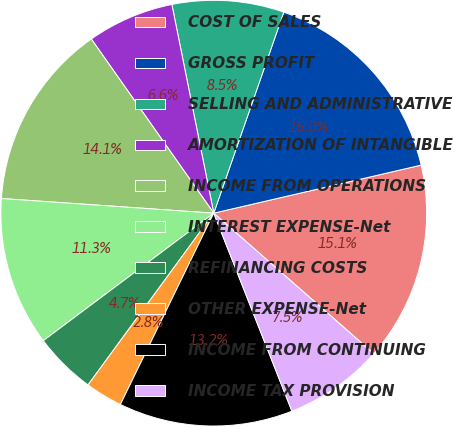<chart> <loc_0><loc_0><loc_500><loc_500><pie_chart><fcel>COST OF SALES<fcel>GROSS PROFIT<fcel>SELLING AND ADMINISTRATIVE<fcel>AMORTIZATION OF INTANGIBLE<fcel>INCOME FROM OPERATIONS<fcel>INTEREST EXPENSE-Net<fcel>REFINANCING COSTS<fcel>OTHER EXPENSE-Net<fcel>INCOME FROM CONTINUING<fcel>INCOME TAX PROVISION<nl><fcel>15.09%<fcel>16.04%<fcel>8.49%<fcel>6.6%<fcel>14.15%<fcel>11.32%<fcel>4.72%<fcel>2.83%<fcel>13.21%<fcel>7.55%<nl></chart> 